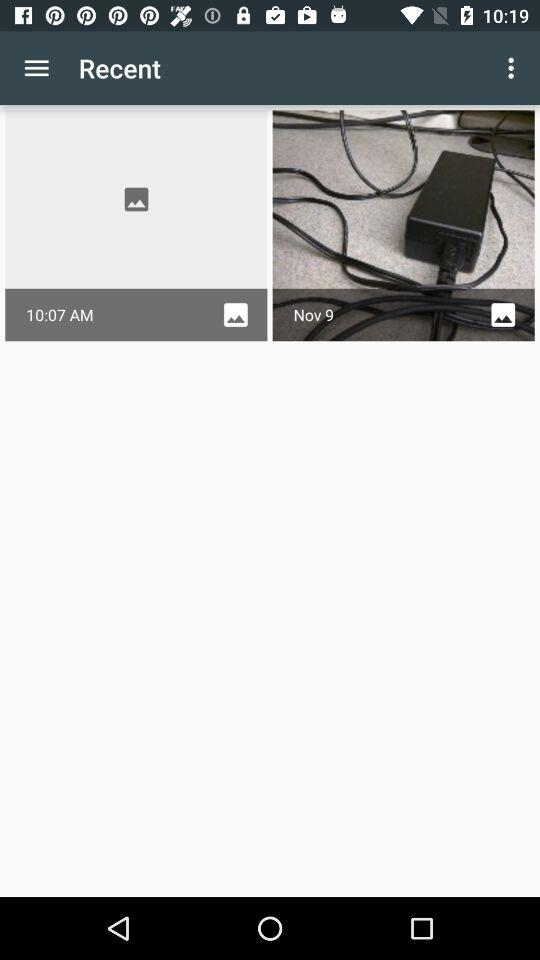What is the time shown on the screen? The time shown on the screen is 10:07 AM. 